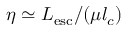<formula> <loc_0><loc_0><loc_500><loc_500>\eta \simeq L _ { e s c } / ( \mu l _ { c } )</formula> 